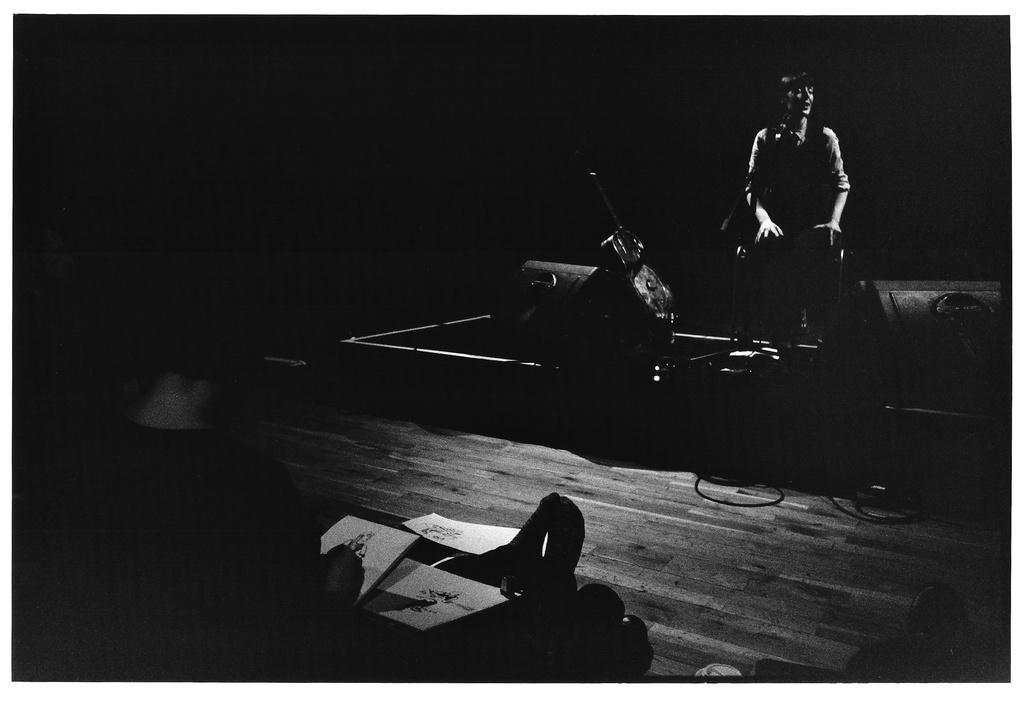Please provide a concise description of this image. It's a black and white image, on the right side a person is sitting. On the left side a person is drawing the picture of that person. 